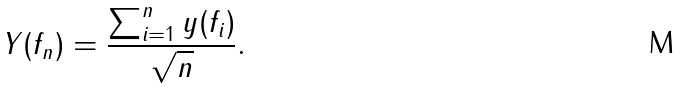Convert formula to latex. <formula><loc_0><loc_0><loc_500><loc_500>Y ( f _ { n } ) = \frac { \sum _ { i = 1 } ^ { n } y ( f _ { i } ) } { \sqrt { n } } .</formula> 